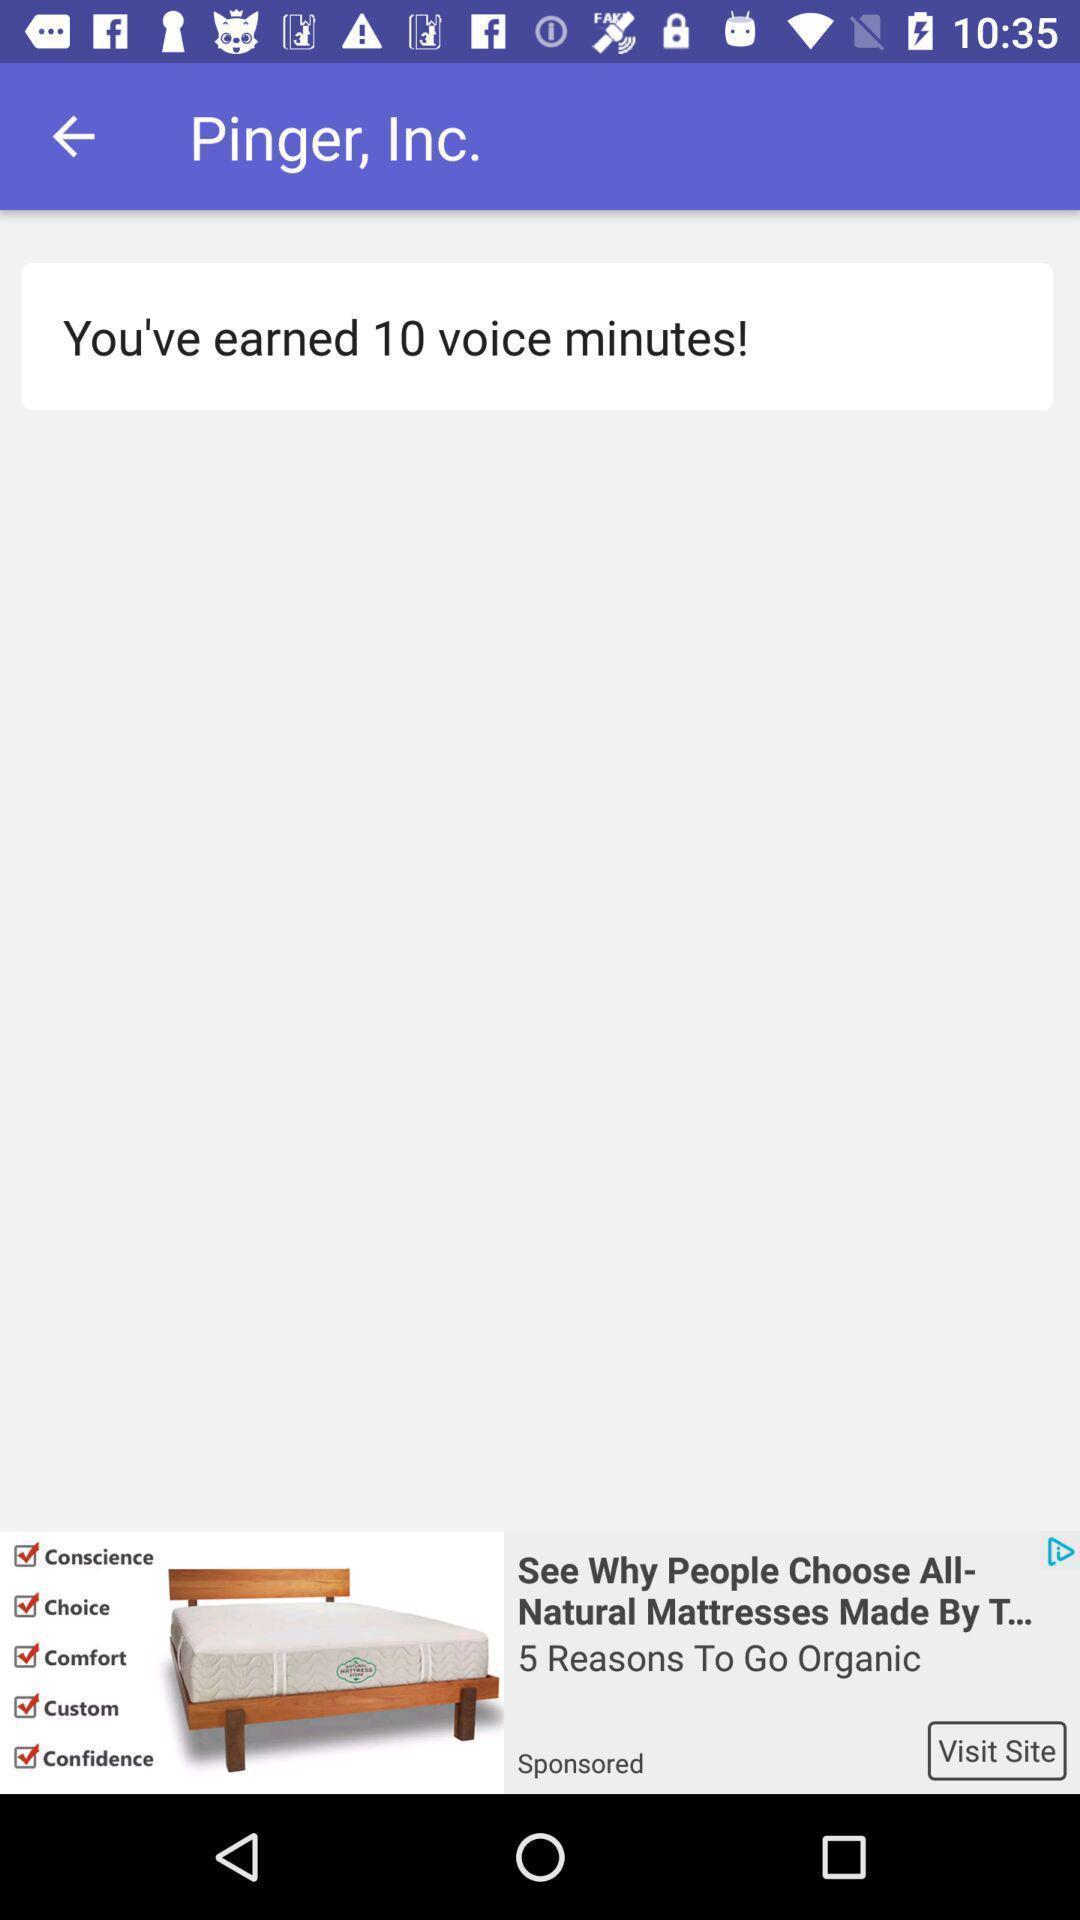Describe the content in this image. Page shows you 've earned 10 voice minutes in calls app. 